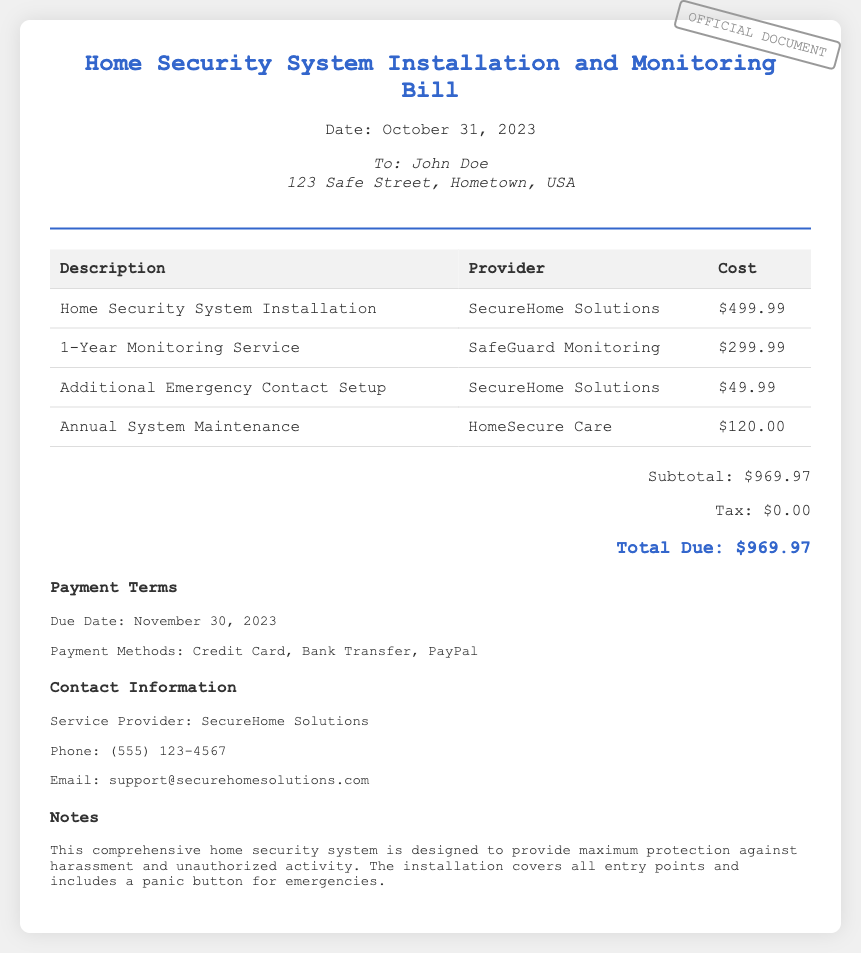What is the date of the bill? The date of the bill is mentioned at the top of the document as "October 31, 2023."
Answer: October 31, 2023 Who is the service provider for installation? The document lists "SecureHome Solutions" as the provider for the home security system installation.
Answer: SecureHome Solutions What is the cost of the 1-Year Monitoring Service? The bill states that the cost for the 1-Year Monitoring Service is $299.99.
Answer: $299.99 What is the total due for the services rendered? The total due is the sum of all costs listed, which is $969.97.
Answer: $969.97 What additional setup is included in the bill? The additional setup includes "Emergency Contact Setup" for $49.99.
Answer: Additional Emergency Contact Setup What is the payment due date? The due date for payment is specified in the payment terms section as "November 30, 2023."
Answer: November 30, 2023 How much is the annual system maintenance cost? The annual system maintenance cost is listed as $120.00 in the document.
Answer: $120.00 What feature is included to enhance harassment prevention? The bill mentions a "panic button" as part of the comprehensive home security system designed for maximum protection against harassment.
Answer: Panic button 